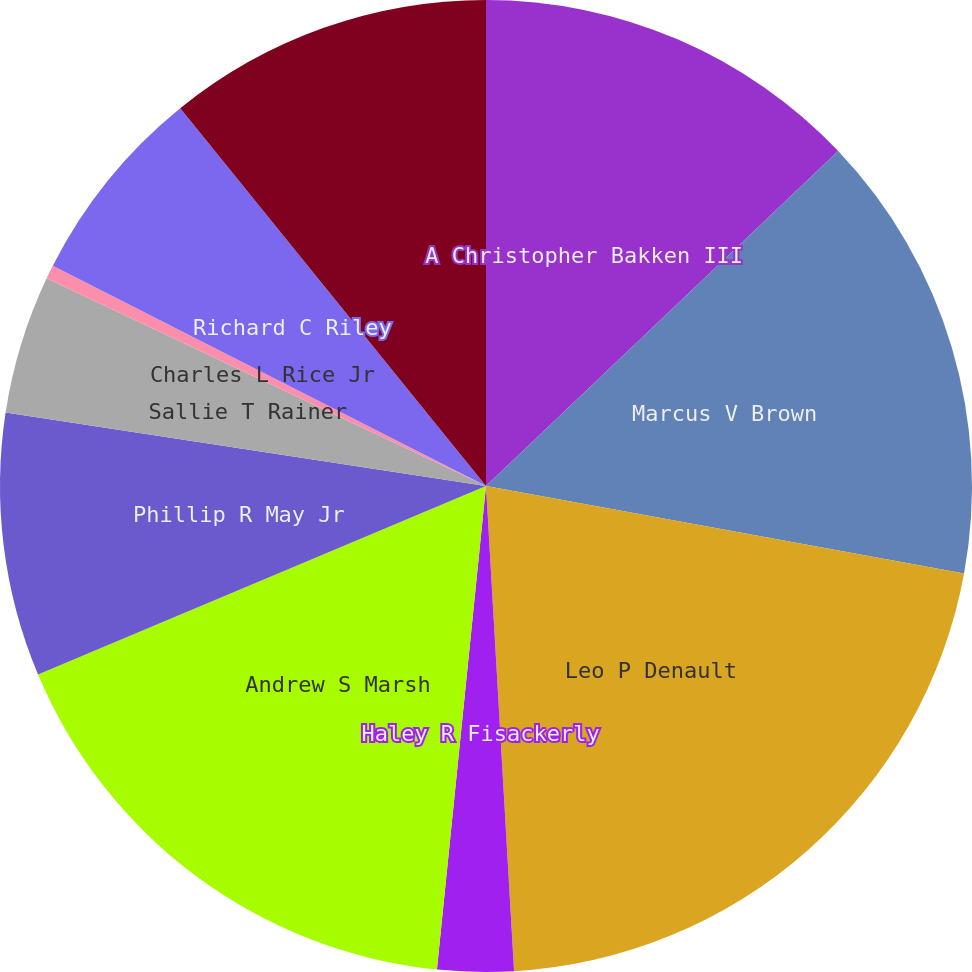Convert chart to OTSL. <chart><loc_0><loc_0><loc_500><loc_500><pie_chart><fcel>A Christopher Bakken III<fcel>Marcus V Brown<fcel>Leo P Denault<fcel>Haley R Fisackerly<fcel>Andrew S Marsh<fcel>Phillip R May Jr<fcel>Sallie T Rainer<fcel>Charles L Rice Jr<fcel>Richard C Riley<fcel>Roderick K West<nl><fcel>12.9%<fcel>14.98%<fcel>21.2%<fcel>2.53%<fcel>17.05%<fcel>8.76%<fcel>4.61%<fcel>0.46%<fcel>6.68%<fcel>10.83%<nl></chart> 